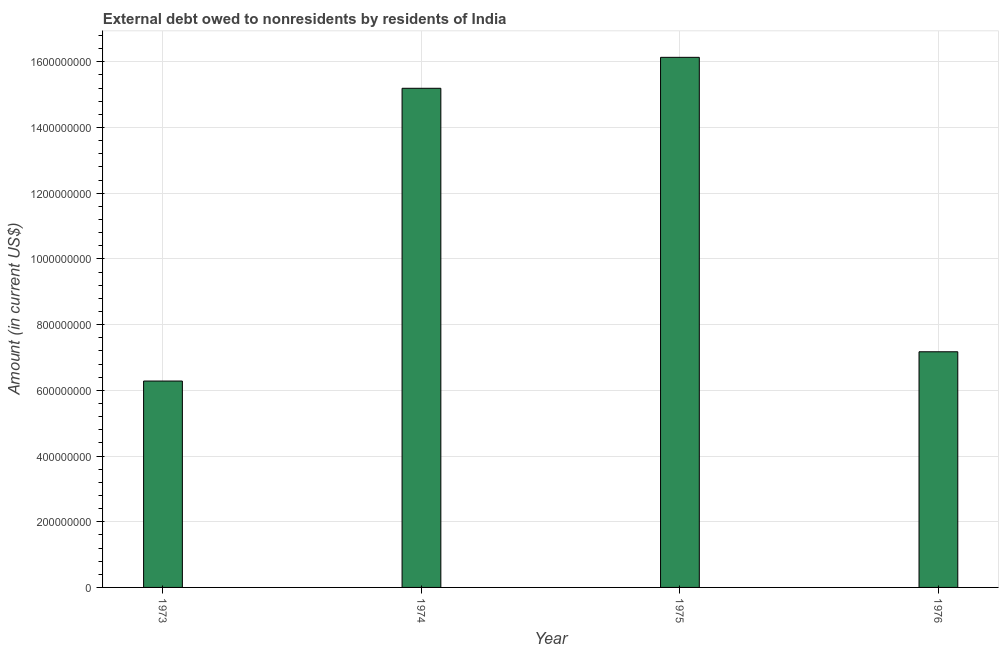Does the graph contain grids?
Provide a succinct answer. Yes. What is the title of the graph?
Offer a terse response. External debt owed to nonresidents by residents of India. What is the label or title of the Y-axis?
Ensure brevity in your answer.  Amount (in current US$). What is the debt in 1974?
Give a very brief answer. 1.52e+09. Across all years, what is the maximum debt?
Give a very brief answer. 1.61e+09. Across all years, what is the minimum debt?
Keep it short and to the point. 6.28e+08. In which year was the debt maximum?
Give a very brief answer. 1975. What is the sum of the debt?
Your answer should be compact. 4.48e+09. What is the difference between the debt in 1973 and 1976?
Your answer should be compact. -8.91e+07. What is the average debt per year?
Offer a very short reply. 1.12e+09. What is the median debt?
Offer a very short reply. 1.12e+09. What is the ratio of the debt in 1973 to that in 1976?
Your response must be concise. 0.88. Is the difference between the debt in 1973 and 1976 greater than the difference between any two years?
Offer a very short reply. No. What is the difference between the highest and the second highest debt?
Keep it short and to the point. 9.42e+07. Is the sum of the debt in 1975 and 1976 greater than the maximum debt across all years?
Your response must be concise. Yes. What is the difference between the highest and the lowest debt?
Offer a terse response. 9.85e+08. What is the difference between two consecutive major ticks on the Y-axis?
Provide a short and direct response. 2.00e+08. What is the Amount (in current US$) of 1973?
Provide a succinct answer. 6.28e+08. What is the Amount (in current US$) in 1974?
Make the answer very short. 1.52e+09. What is the Amount (in current US$) of 1975?
Your response must be concise. 1.61e+09. What is the Amount (in current US$) in 1976?
Your response must be concise. 7.17e+08. What is the difference between the Amount (in current US$) in 1973 and 1974?
Keep it short and to the point. -8.91e+08. What is the difference between the Amount (in current US$) in 1973 and 1975?
Your response must be concise. -9.85e+08. What is the difference between the Amount (in current US$) in 1973 and 1976?
Offer a very short reply. -8.91e+07. What is the difference between the Amount (in current US$) in 1974 and 1975?
Your answer should be very brief. -9.42e+07. What is the difference between the Amount (in current US$) in 1974 and 1976?
Your answer should be very brief. 8.02e+08. What is the difference between the Amount (in current US$) in 1975 and 1976?
Provide a succinct answer. 8.96e+08. What is the ratio of the Amount (in current US$) in 1973 to that in 1974?
Provide a succinct answer. 0.41. What is the ratio of the Amount (in current US$) in 1973 to that in 1975?
Your response must be concise. 0.39. What is the ratio of the Amount (in current US$) in 1973 to that in 1976?
Offer a terse response. 0.88. What is the ratio of the Amount (in current US$) in 1974 to that in 1975?
Provide a succinct answer. 0.94. What is the ratio of the Amount (in current US$) in 1974 to that in 1976?
Your response must be concise. 2.12. What is the ratio of the Amount (in current US$) in 1975 to that in 1976?
Your answer should be very brief. 2.25. 